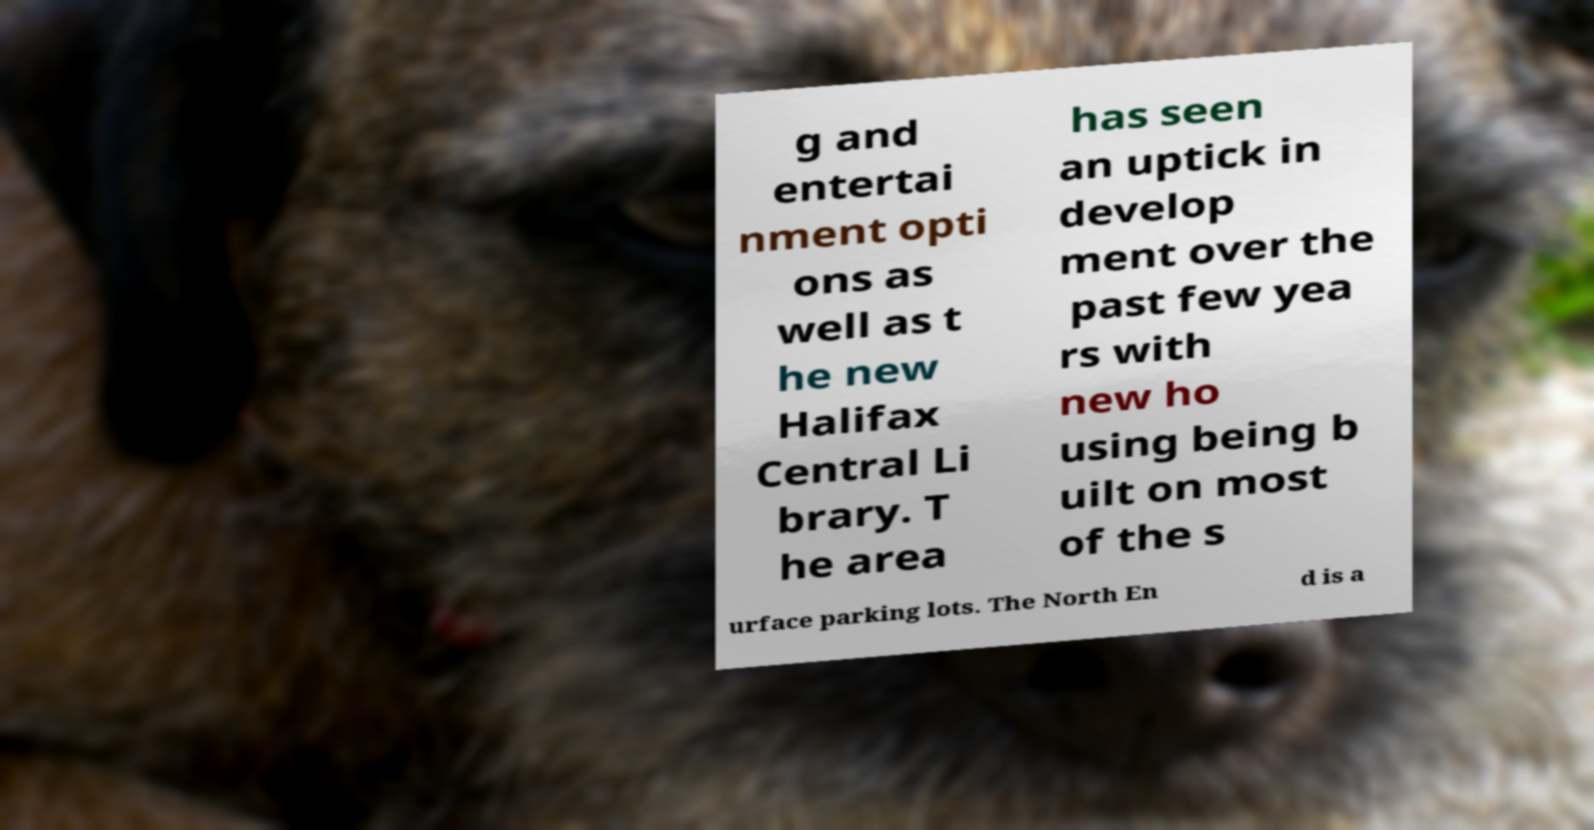Could you extract and type out the text from this image? g and entertai nment opti ons as well as t he new Halifax Central Li brary. T he area has seen an uptick in develop ment over the past few yea rs with new ho using being b uilt on most of the s urface parking lots. The North En d is a 